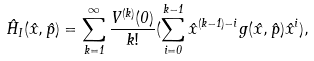<formula> <loc_0><loc_0><loc_500><loc_500>\hat { H } _ { I } ( \hat { x } , \hat { p } ) = \sum _ { k = 1 } ^ { \infty } \frac { V ^ { ( k ) } ( 0 ) } { k ! } ( \sum _ { i = 0 } ^ { k - 1 } \hat { x } ^ { ( k - 1 ) - i } g ( \hat { x } , \hat { p } ) \hat { x } ^ { i } ) ,</formula> 